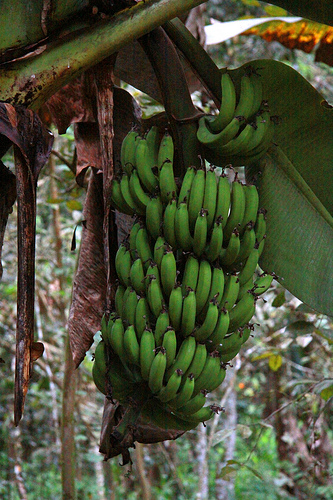Please provide a short description for this region: [0.56, 0.22, 0.65, 0.3]. This region shows part of a green banana. 